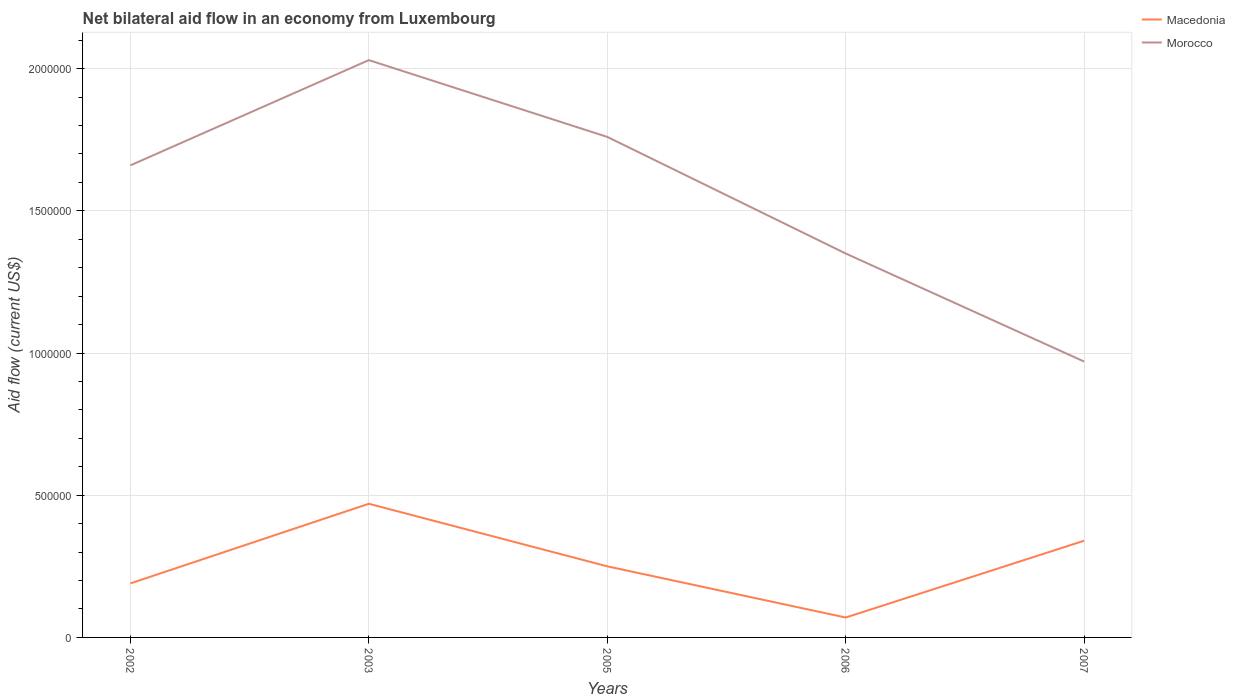Across all years, what is the maximum net bilateral aid flow in Macedonia?
Make the answer very short. 7.00e+04. Is the net bilateral aid flow in Morocco strictly greater than the net bilateral aid flow in Macedonia over the years?
Keep it short and to the point. No. How many years are there in the graph?
Your answer should be very brief. 5. Are the values on the major ticks of Y-axis written in scientific E-notation?
Offer a very short reply. No. Does the graph contain any zero values?
Ensure brevity in your answer.  No. Does the graph contain grids?
Give a very brief answer. Yes. Where does the legend appear in the graph?
Provide a short and direct response. Top right. What is the title of the graph?
Make the answer very short. Net bilateral aid flow in an economy from Luxembourg. What is the Aid flow (current US$) of Macedonia in 2002?
Offer a terse response. 1.90e+05. What is the Aid flow (current US$) in Morocco in 2002?
Ensure brevity in your answer.  1.66e+06. What is the Aid flow (current US$) in Macedonia in 2003?
Offer a terse response. 4.70e+05. What is the Aid flow (current US$) in Morocco in 2003?
Your answer should be compact. 2.03e+06. What is the Aid flow (current US$) in Macedonia in 2005?
Make the answer very short. 2.50e+05. What is the Aid flow (current US$) in Morocco in 2005?
Offer a very short reply. 1.76e+06. What is the Aid flow (current US$) of Macedonia in 2006?
Offer a terse response. 7.00e+04. What is the Aid flow (current US$) of Morocco in 2006?
Provide a succinct answer. 1.35e+06. What is the Aid flow (current US$) of Morocco in 2007?
Give a very brief answer. 9.70e+05. Across all years, what is the maximum Aid flow (current US$) of Macedonia?
Make the answer very short. 4.70e+05. Across all years, what is the maximum Aid flow (current US$) in Morocco?
Ensure brevity in your answer.  2.03e+06. Across all years, what is the minimum Aid flow (current US$) in Macedonia?
Provide a short and direct response. 7.00e+04. Across all years, what is the minimum Aid flow (current US$) of Morocco?
Offer a very short reply. 9.70e+05. What is the total Aid flow (current US$) in Macedonia in the graph?
Provide a short and direct response. 1.32e+06. What is the total Aid flow (current US$) in Morocco in the graph?
Provide a succinct answer. 7.77e+06. What is the difference between the Aid flow (current US$) of Macedonia in 2002 and that in 2003?
Ensure brevity in your answer.  -2.80e+05. What is the difference between the Aid flow (current US$) in Morocco in 2002 and that in 2003?
Provide a short and direct response. -3.70e+05. What is the difference between the Aid flow (current US$) in Morocco in 2002 and that in 2005?
Keep it short and to the point. -1.00e+05. What is the difference between the Aid flow (current US$) of Macedonia in 2002 and that in 2006?
Offer a terse response. 1.20e+05. What is the difference between the Aid flow (current US$) of Macedonia in 2002 and that in 2007?
Provide a short and direct response. -1.50e+05. What is the difference between the Aid flow (current US$) in Morocco in 2002 and that in 2007?
Offer a terse response. 6.90e+05. What is the difference between the Aid flow (current US$) in Macedonia in 2003 and that in 2005?
Provide a short and direct response. 2.20e+05. What is the difference between the Aid flow (current US$) of Morocco in 2003 and that in 2006?
Your response must be concise. 6.80e+05. What is the difference between the Aid flow (current US$) of Morocco in 2003 and that in 2007?
Offer a very short reply. 1.06e+06. What is the difference between the Aid flow (current US$) in Morocco in 2005 and that in 2006?
Ensure brevity in your answer.  4.10e+05. What is the difference between the Aid flow (current US$) of Macedonia in 2005 and that in 2007?
Provide a short and direct response. -9.00e+04. What is the difference between the Aid flow (current US$) in Morocco in 2005 and that in 2007?
Offer a very short reply. 7.90e+05. What is the difference between the Aid flow (current US$) in Macedonia in 2006 and that in 2007?
Provide a succinct answer. -2.70e+05. What is the difference between the Aid flow (current US$) of Morocco in 2006 and that in 2007?
Make the answer very short. 3.80e+05. What is the difference between the Aid flow (current US$) of Macedonia in 2002 and the Aid flow (current US$) of Morocco in 2003?
Keep it short and to the point. -1.84e+06. What is the difference between the Aid flow (current US$) in Macedonia in 2002 and the Aid flow (current US$) in Morocco in 2005?
Give a very brief answer. -1.57e+06. What is the difference between the Aid flow (current US$) in Macedonia in 2002 and the Aid flow (current US$) in Morocco in 2006?
Offer a terse response. -1.16e+06. What is the difference between the Aid flow (current US$) of Macedonia in 2002 and the Aid flow (current US$) of Morocco in 2007?
Your answer should be compact. -7.80e+05. What is the difference between the Aid flow (current US$) in Macedonia in 2003 and the Aid flow (current US$) in Morocco in 2005?
Give a very brief answer. -1.29e+06. What is the difference between the Aid flow (current US$) of Macedonia in 2003 and the Aid flow (current US$) of Morocco in 2006?
Offer a very short reply. -8.80e+05. What is the difference between the Aid flow (current US$) in Macedonia in 2003 and the Aid flow (current US$) in Morocco in 2007?
Provide a succinct answer. -5.00e+05. What is the difference between the Aid flow (current US$) of Macedonia in 2005 and the Aid flow (current US$) of Morocco in 2006?
Your answer should be compact. -1.10e+06. What is the difference between the Aid flow (current US$) in Macedonia in 2005 and the Aid flow (current US$) in Morocco in 2007?
Make the answer very short. -7.20e+05. What is the difference between the Aid flow (current US$) in Macedonia in 2006 and the Aid flow (current US$) in Morocco in 2007?
Your answer should be very brief. -9.00e+05. What is the average Aid flow (current US$) of Macedonia per year?
Provide a succinct answer. 2.64e+05. What is the average Aid flow (current US$) in Morocco per year?
Give a very brief answer. 1.55e+06. In the year 2002, what is the difference between the Aid flow (current US$) of Macedonia and Aid flow (current US$) of Morocco?
Ensure brevity in your answer.  -1.47e+06. In the year 2003, what is the difference between the Aid flow (current US$) of Macedonia and Aid flow (current US$) of Morocco?
Keep it short and to the point. -1.56e+06. In the year 2005, what is the difference between the Aid flow (current US$) in Macedonia and Aid flow (current US$) in Morocco?
Provide a short and direct response. -1.51e+06. In the year 2006, what is the difference between the Aid flow (current US$) in Macedonia and Aid flow (current US$) in Morocco?
Keep it short and to the point. -1.28e+06. In the year 2007, what is the difference between the Aid flow (current US$) of Macedonia and Aid flow (current US$) of Morocco?
Your answer should be compact. -6.30e+05. What is the ratio of the Aid flow (current US$) in Macedonia in 2002 to that in 2003?
Your answer should be very brief. 0.4. What is the ratio of the Aid flow (current US$) of Morocco in 2002 to that in 2003?
Provide a short and direct response. 0.82. What is the ratio of the Aid flow (current US$) in Macedonia in 2002 to that in 2005?
Your answer should be compact. 0.76. What is the ratio of the Aid flow (current US$) in Morocco in 2002 to that in 2005?
Your answer should be very brief. 0.94. What is the ratio of the Aid flow (current US$) in Macedonia in 2002 to that in 2006?
Your answer should be compact. 2.71. What is the ratio of the Aid flow (current US$) of Morocco in 2002 to that in 2006?
Keep it short and to the point. 1.23. What is the ratio of the Aid flow (current US$) in Macedonia in 2002 to that in 2007?
Your answer should be compact. 0.56. What is the ratio of the Aid flow (current US$) in Morocco in 2002 to that in 2007?
Your answer should be very brief. 1.71. What is the ratio of the Aid flow (current US$) of Macedonia in 2003 to that in 2005?
Offer a terse response. 1.88. What is the ratio of the Aid flow (current US$) of Morocco in 2003 to that in 2005?
Give a very brief answer. 1.15. What is the ratio of the Aid flow (current US$) in Macedonia in 2003 to that in 2006?
Offer a very short reply. 6.71. What is the ratio of the Aid flow (current US$) of Morocco in 2003 to that in 2006?
Offer a terse response. 1.5. What is the ratio of the Aid flow (current US$) of Macedonia in 2003 to that in 2007?
Your response must be concise. 1.38. What is the ratio of the Aid flow (current US$) in Morocco in 2003 to that in 2007?
Offer a terse response. 2.09. What is the ratio of the Aid flow (current US$) in Macedonia in 2005 to that in 2006?
Your response must be concise. 3.57. What is the ratio of the Aid flow (current US$) in Morocco in 2005 to that in 2006?
Your answer should be compact. 1.3. What is the ratio of the Aid flow (current US$) of Macedonia in 2005 to that in 2007?
Your response must be concise. 0.74. What is the ratio of the Aid flow (current US$) in Morocco in 2005 to that in 2007?
Your answer should be compact. 1.81. What is the ratio of the Aid flow (current US$) in Macedonia in 2006 to that in 2007?
Give a very brief answer. 0.21. What is the ratio of the Aid flow (current US$) in Morocco in 2006 to that in 2007?
Ensure brevity in your answer.  1.39. What is the difference between the highest and the lowest Aid flow (current US$) of Morocco?
Make the answer very short. 1.06e+06. 